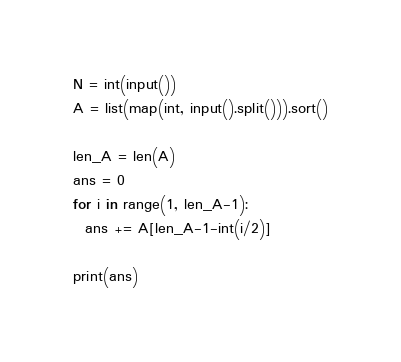Convert code to text. <code><loc_0><loc_0><loc_500><loc_500><_Python_>N = int(input())
A = list(map(int, input().split())).sort()

len_A = len(A)
ans = 0
for i in range(1, len_A-1):
  ans += A[len_A-1-int(i/2)]

print(ans)</code> 